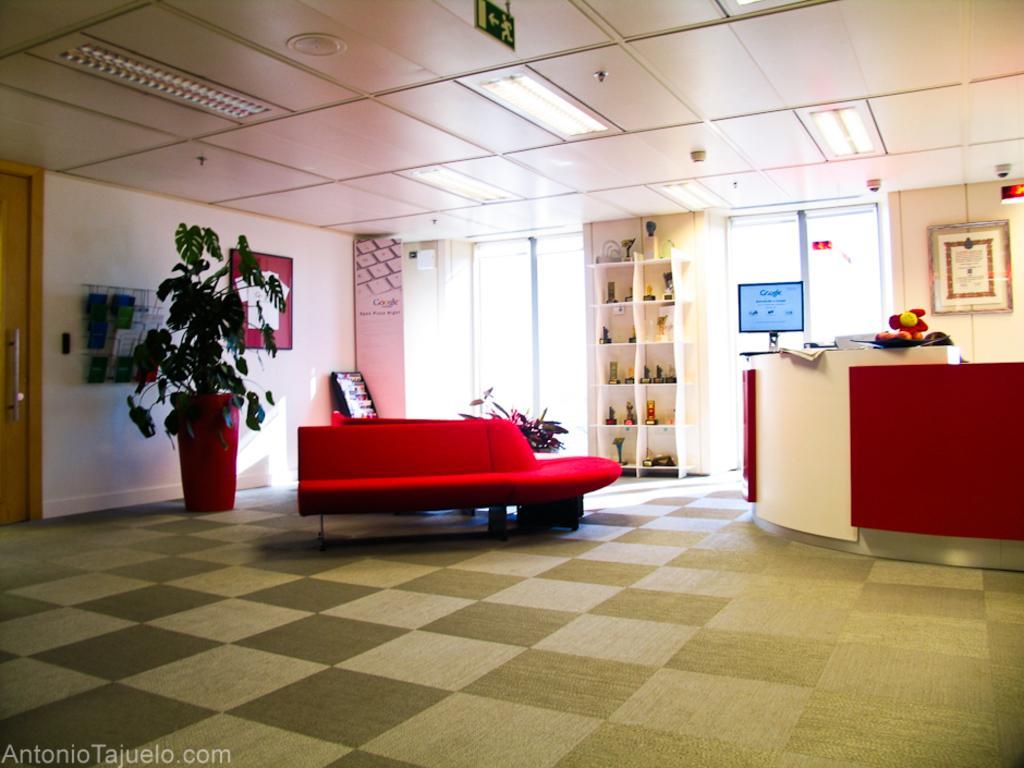In one or two sentences, can you explain what this image depicts? As we can see in the image there is a red colour sofa and behind it there is a red colour pot on which there is a plant and on the top there is a tubelight and on the wall there is a notice board on which papers are sticked and at the opposite there is a reception on which a monitor is placed and on the other side of the monitor there is a wardrobe on which medals and trophies are kept. 